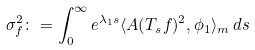<formula> <loc_0><loc_0><loc_500><loc_500>\sigma _ { f } ^ { 2 } \colon = \int _ { 0 } ^ { \infty } e ^ { \lambda _ { 1 } s } \langle A ( T _ { s } f ) ^ { 2 } , \phi _ { 1 } \rangle _ { m } \, d s</formula> 